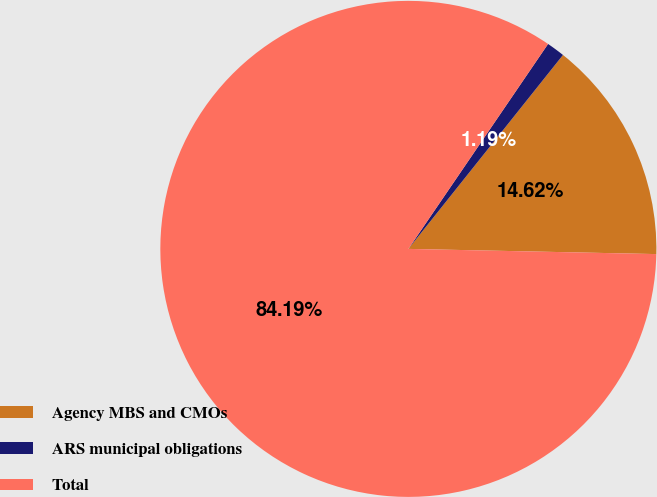Convert chart to OTSL. <chart><loc_0><loc_0><loc_500><loc_500><pie_chart><fcel>Agency MBS and CMOs<fcel>ARS municipal obligations<fcel>Total<nl><fcel>14.62%<fcel>1.19%<fcel>84.19%<nl></chart> 